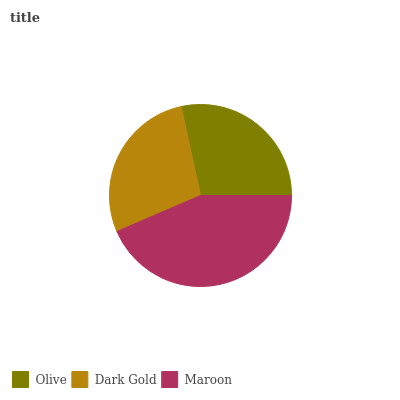Is Dark Gold the minimum?
Answer yes or no. Yes. Is Maroon the maximum?
Answer yes or no. Yes. Is Maroon the minimum?
Answer yes or no. No. Is Dark Gold the maximum?
Answer yes or no. No. Is Maroon greater than Dark Gold?
Answer yes or no. Yes. Is Dark Gold less than Maroon?
Answer yes or no. Yes. Is Dark Gold greater than Maroon?
Answer yes or no. No. Is Maroon less than Dark Gold?
Answer yes or no. No. Is Olive the high median?
Answer yes or no. Yes. Is Olive the low median?
Answer yes or no. Yes. Is Dark Gold the high median?
Answer yes or no. No. Is Maroon the low median?
Answer yes or no. No. 